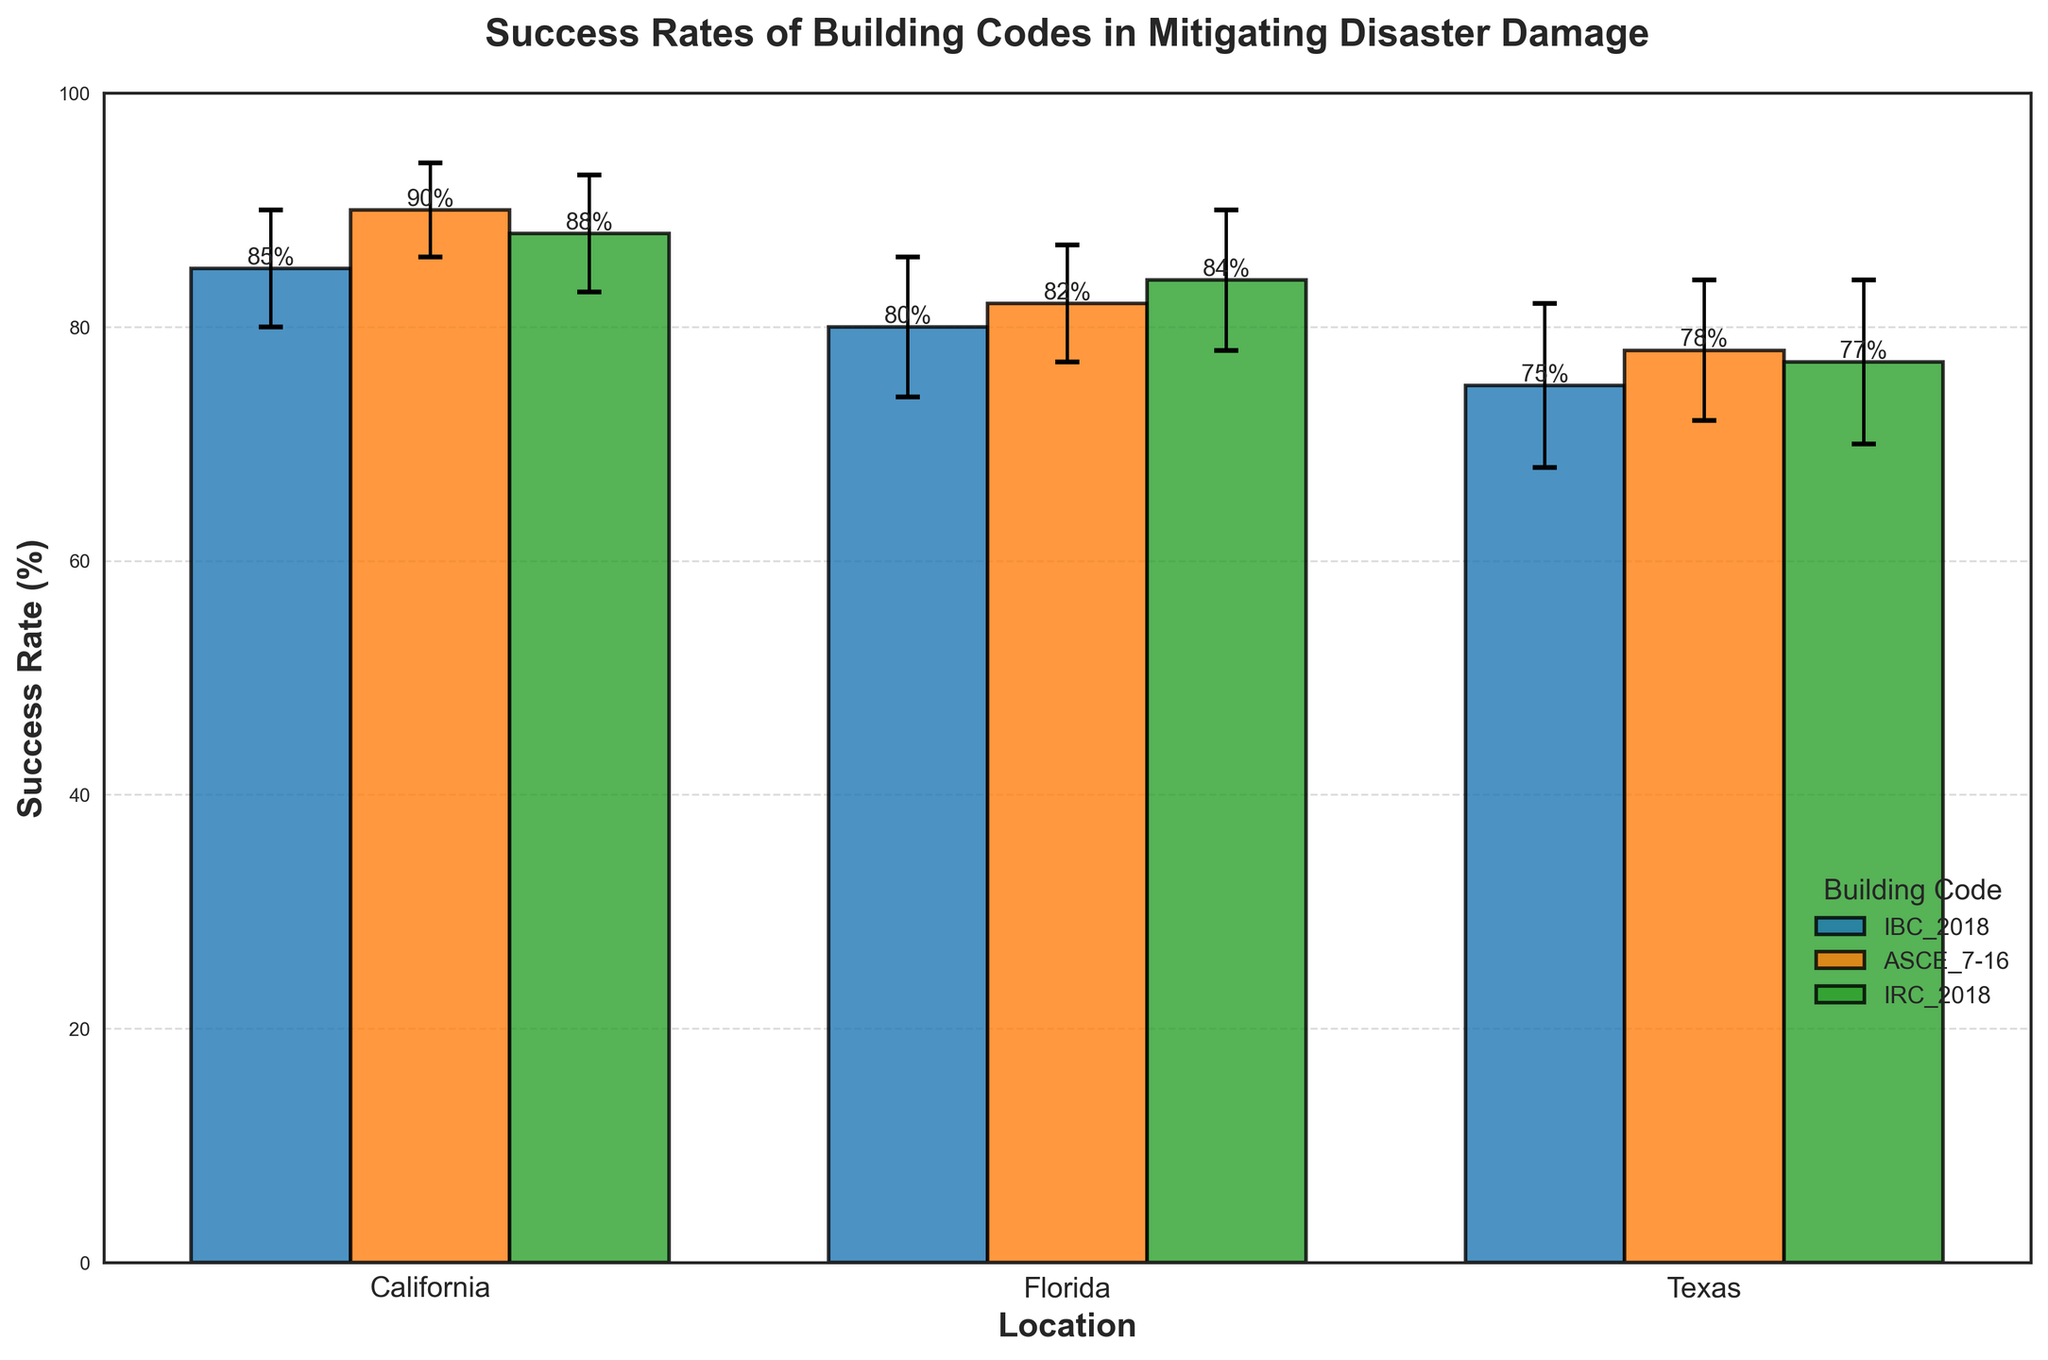what is the title of the chart? The title of the chart is "Success Rates of Building Codes in Mitigating Disaster Damage," which is displayed at the top of the figure.
Answer: Success Rates of Building Codes in Mitigating Disaster Damage Which location has the highest success rate, and under which building code? Compare the success rates for all locations and building codes. The highest success rate is for ASCE_7-16 in California with a success rate of 90%.
Answer: California, ASCE_7-16 What is the difference in success rates between IBC_2018 and IRC_2018 in Florida? The success rate for IBC_2018 in Florida is 80% and for IRC_2018 in Florida is 84%. The difference is 84% - 80% = 4%.
Answer: 4% Which building code has the lowest success rate in Texas, and what is it? Compare the success rates for all building codes in Texas. The lowest success rate is for IBC_2018 with a success rate of 75%.
Answer: IBC_2018, 75% How does the success rate of ASCE_7-16 in Florida compare to the success rate of IRC_2018 in California? The success rate of ASCE_7-16 in Florida is 82%, and the success rate of IRC_2018 in California is 88%. By comparing the two, we see that IRC_2018 in California has a higher success rate.
Answer: IRC_2018 in California is higher What is the average success rate across all building codes in Texas? Calculate the average success rate for Texas by summing the rates (75% + 78% + 77%) and dividing by the number of building codes (3). The result is (75 + 78 + 77) / 3 = 76.67%.
Answer: 76.67% What is the confidence interval range for IRC_2018 in Florida? The confidence interval for IRC_2018 in Florida is 84% with a confidence interval of 6%. The range is 84% ± 6%, making it 78% to 90%.
Answer: 78% to 90% Compare the overall variation in success rates between California and Texas. Calculate the range (difference between highest and lowest success rates) for each:
California: 90% (ASCE_7-16) - 85% (IBC_2018) = 5%.
Texas: 78% (ASCE_7-16) - 75% (IBC_2018) = 3%.
California has a greater variation in success rates.
Answer: California has greater variation Why might it be significant to include confidence intervals in this chart? Confidence intervals provide an estimate of uncertainty around the success rates, showing the range in which the true rate might lie with a certain level of confidence. This aids in understanding the reliability of the success rate estimates.
Answer: They show the uncertainty and reliability of the estimates Between IBC_2018 and ASCE_7-16 in Florida, which has a wider confidence interval, and what does this indicate? IBC_2018 has a confidence interval of 6% and ASCE_7-16 has a confidence interval of 5%. IBC_2018 has a slightly wider confidence interval, indicating slightly more uncertainty in its success rate estimate.
Answer: IBC_2018, more uncertainty 